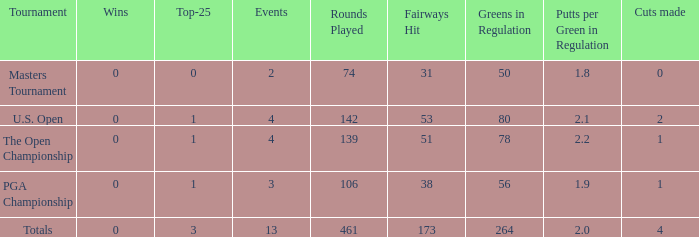How many cuts did he make at the PGA championship in 3 events? None. 